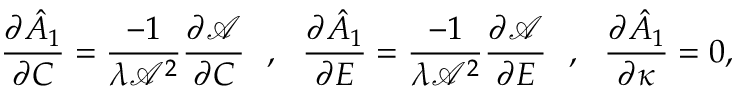<formula> <loc_0><loc_0><loc_500><loc_500>\frac { \partial \hat { A } _ { 1 } } { \partial C } = \frac { - 1 } { \lambda \mathcal { A } ^ { 2 } } \frac { \partial \mathcal { A } } { \partial C } , \frac { \partial \hat { A } _ { 1 } } { \partial E } = \frac { - 1 } { \lambda \mathcal { A } ^ { 2 } } \frac { \partial \mathcal { A } } { \partial E } , \frac { \partial \hat { A } _ { 1 } } { \partial \kappa } = 0 ,</formula> 